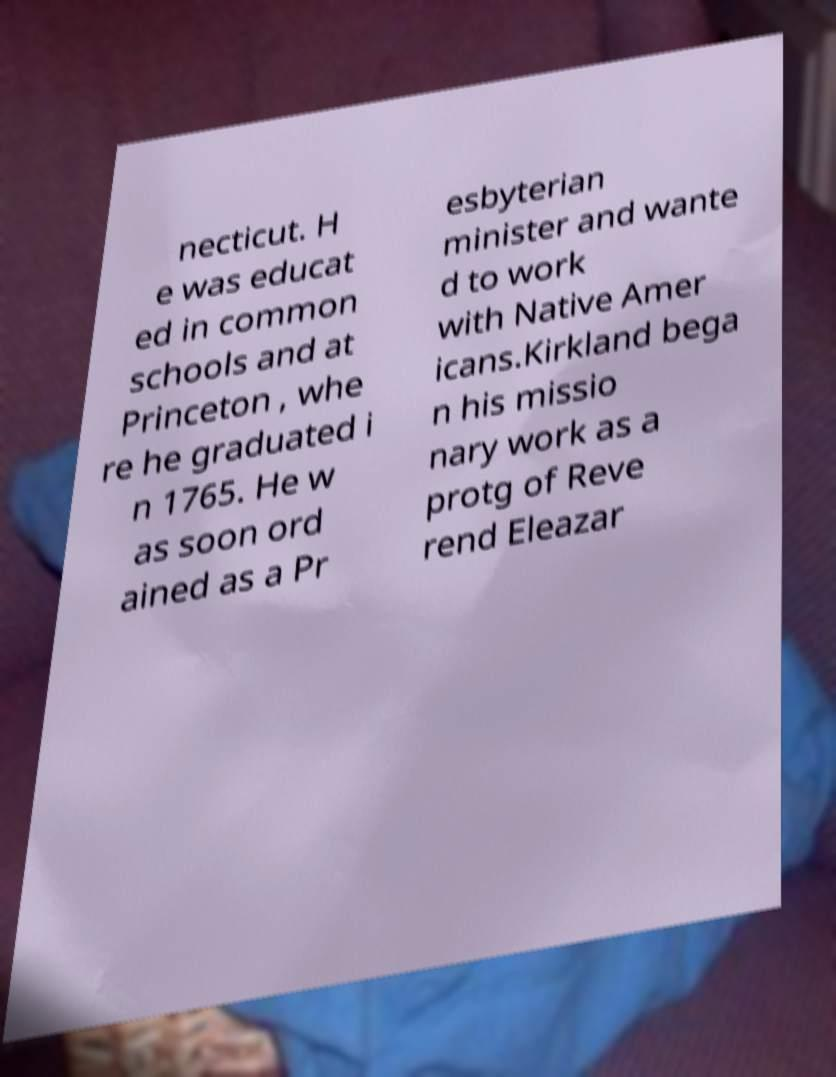Can you accurately transcribe the text from the provided image for me? necticut. H e was educat ed in common schools and at Princeton , whe re he graduated i n 1765. He w as soon ord ained as a Pr esbyterian minister and wante d to work with Native Amer icans.Kirkland bega n his missio nary work as a protg of Reve rend Eleazar 